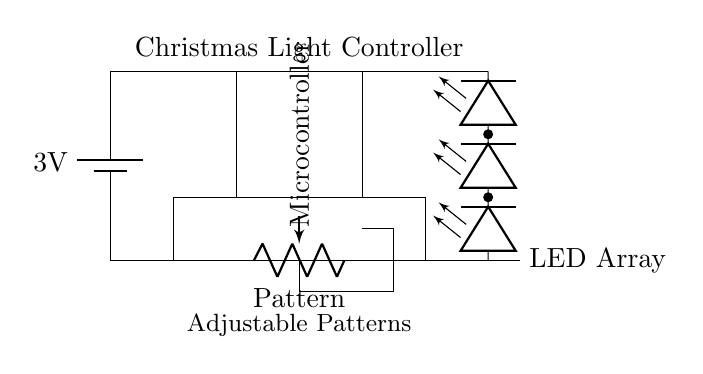What is the voltage of the battery? The voltage is labeled as 3 volts, which indicates the potential difference provided by the battery in the circuit.
Answer: 3 volts What type of component is the microcontroller? The microcontroller is depicted as a rectangular block in the diagram and serves as the control unit, indicating it's likely an integrated circuit.
Answer: Microcontroller How many LEDs are shown in the array? The LED array shows three individual LEDs connected in parallel, as indicated by the symbols for the LEDo components stacked vertically.
Answer: Three What is the purpose of the potentiometer? The potentiometer is labeled as "Pattern," suggesting its function is to adjust the light patterns of the LEDs based on the resistance it provides in the circuit.
Answer: Adjust light patterns What is the function of the connections in this circuit? The connections in the circuit diagram link the battery, microcontroller, and LED array, allowing current to flow and enabling the controller to power and control the LEDs.
Answer: Connect components How does the adjustable patterns feature work? The adjustable patterns feature operates through the potentiometer, which modifies the circuit resistance, allowing the microcontroller to change the blinking patterns of the LEDs based on the resistance setting.
Answer: Modify blinking patterns 